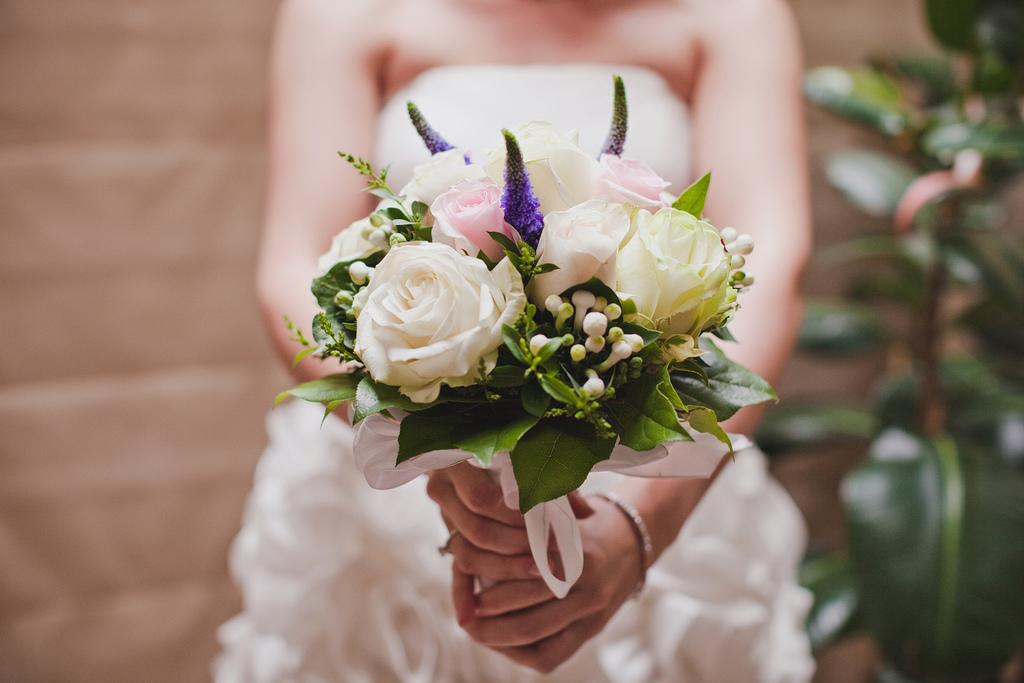Who is the main subject in the image? There is a woman standing in the middle of the image. What is the woman holding in her hand? The woman is holding flowers in her hand. What can be seen on the right side of the image? There is a plant on the right side of the image. What type of parent is the woman in the image? The image does not provide any information about the woman's parental status, so it cannot be determined from the image. 